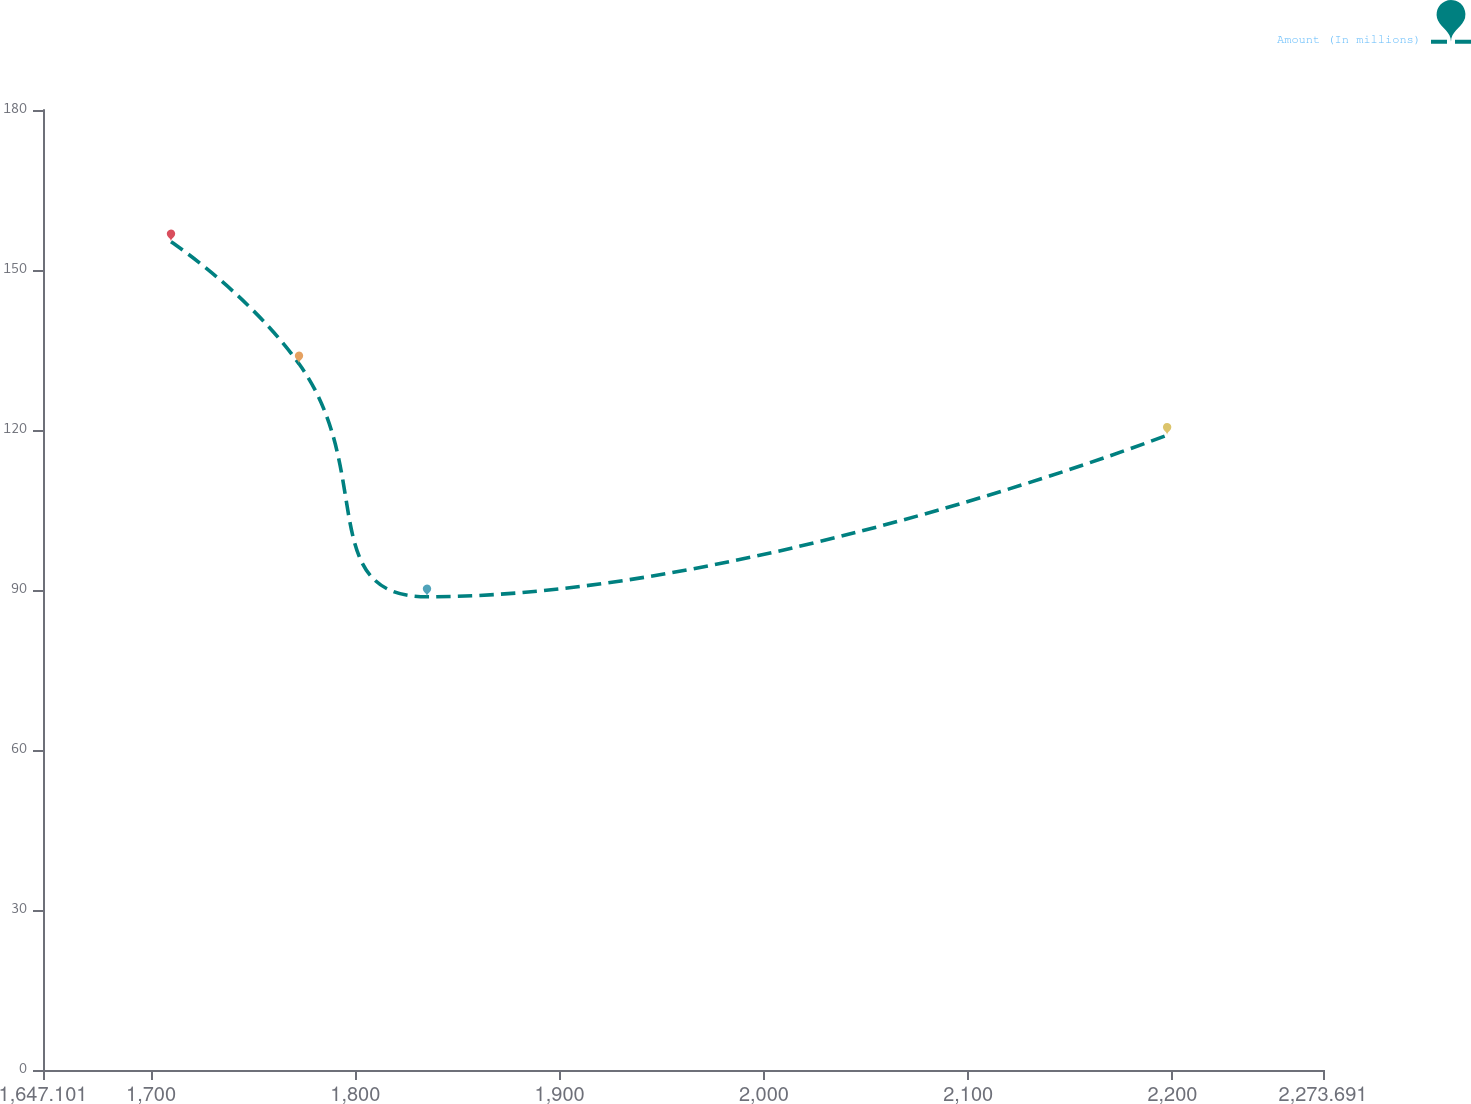<chart> <loc_0><loc_0><loc_500><loc_500><line_chart><ecel><fcel>Amount (In millions)<nl><fcel>1709.76<fcel>155.3<nl><fcel>1772.42<fcel>132.41<nl><fcel>1835.08<fcel>88.73<nl><fcel>2197.39<fcel>119.04<nl><fcel>2336.35<fcel>95.39<nl></chart> 